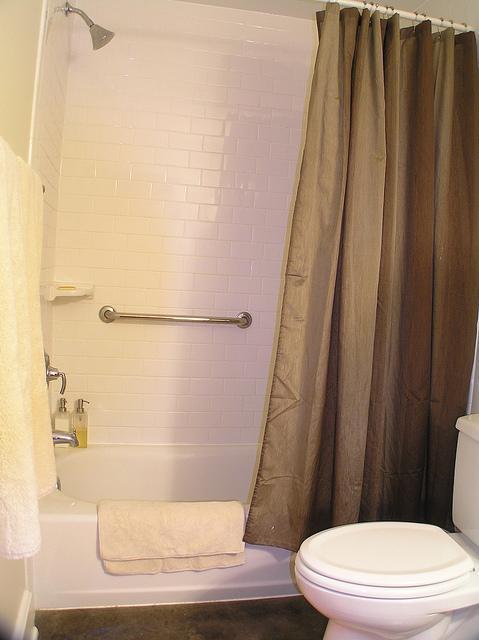How many bottles are in the shower?
Give a very brief answer. 2. 